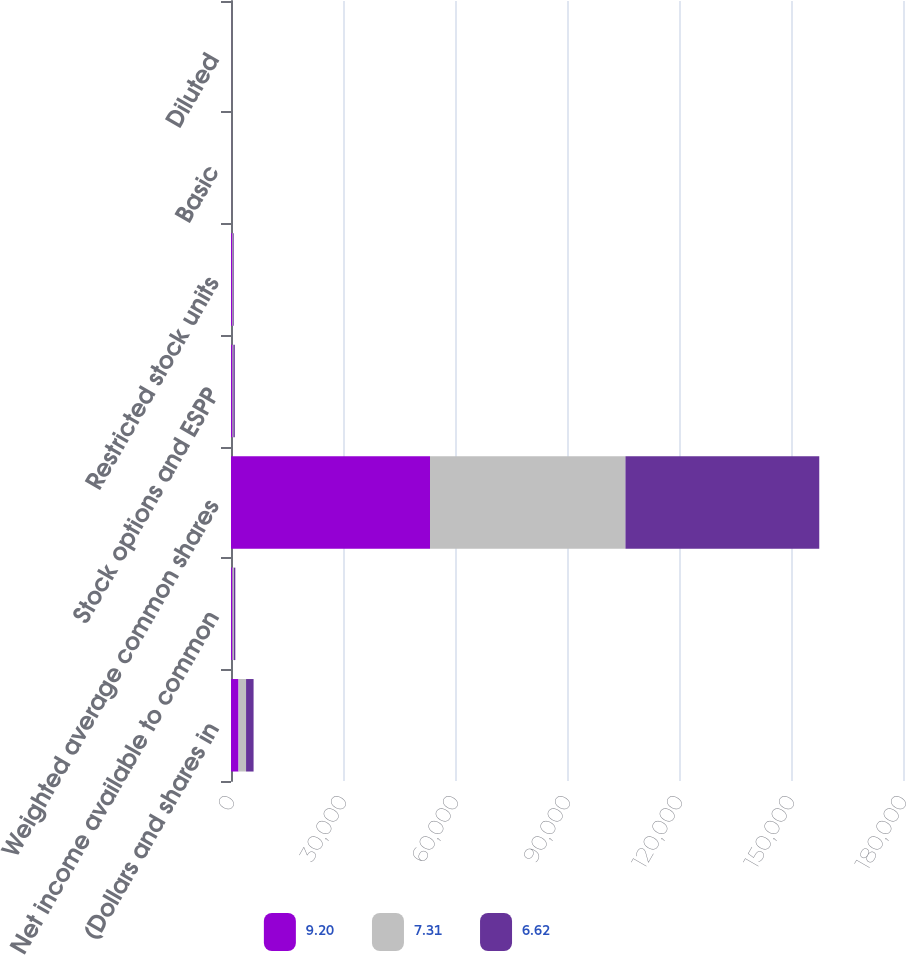Convert chart to OTSL. <chart><loc_0><loc_0><loc_500><loc_500><stacked_bar_chart><ecel><fcel>(Dollars and shares in<fcel>Net income available to common<fcel>Weighted average common shares<fcel>Stock options and ESPP<fcel>Restricted stock units<fcel>Basic<fcel>Diluted<nl><fcel>9.2<fcel>2017<fcel>385<fcel>53306<fcel>385<fcel>333<fcel>9.33<fcel>9.2<nl><fcel>7.31<fcel>2016<fcel>385<fcel>52349<fcel>254<fcel>180<fcel>7.37<fcel>7.31<nl><fcel>6.62<fcel>2015<fcel>385<fcel>51916<fcel>387<fcel>211<fcel>6.7<fcel>6.62<nl></chart> 